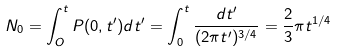<formula> <loc_0><loc_0><loc_500><loc_500>N _ { 0 } = \int _ { O } ^ { t } P ( 0 , t ^ { \prime } ) d t ^ { \prime } = \int _ { 0 } ^ { t } \frac { d t ^ { \prime } } { ( 2 \pi t ^ { \prime } ) ^ { 3 / 4 } } = \frac { 2 } { 3 } \pi t ^ { 1 / 4 }</formula> 